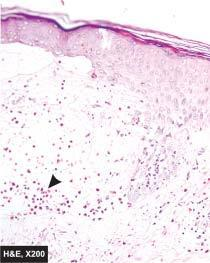what shows non-acantholytic subepidermal bulla containing microabscess of eosinophils?
Answer the question using a single word or phrase. Skin 